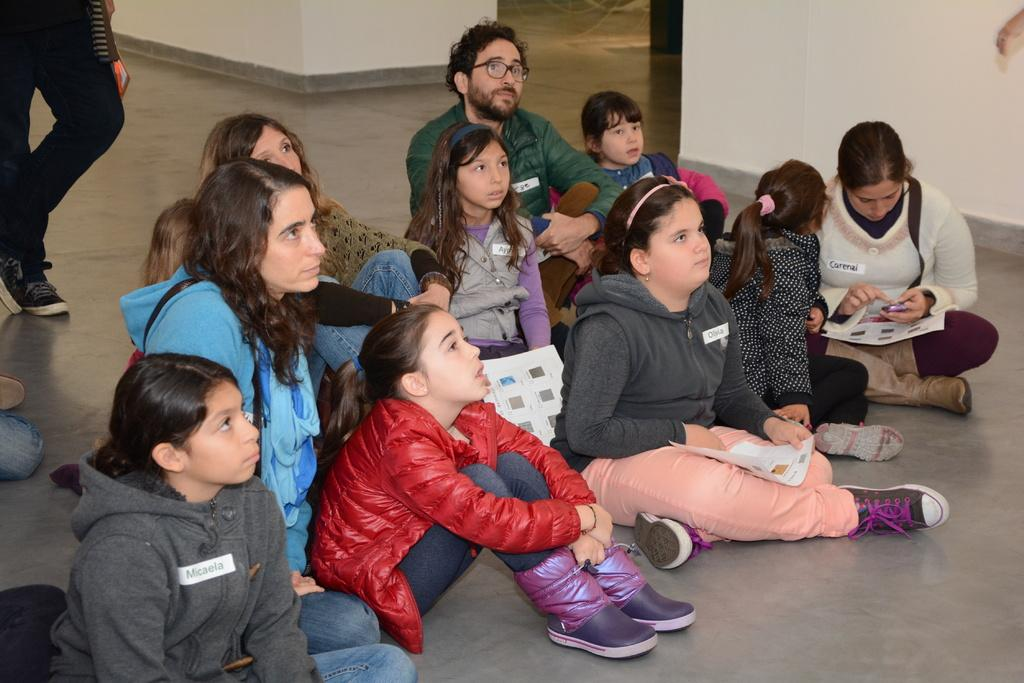What are the people in the image doing? There is a group of people sitting on the floor in the image. Are there any other people in the image besides those sitting on the floor? Yes, there is a person standing in the image. What can be seen in the background of the image? There is a wall visible in the background of the image. Where is the lunchroom located in the image? There is no mention of a lunchroom in the image; it only shows a group of people sitting on the floor and a person standing. What type of hat is the person wearing in the image? There is no person wearing a hat in the image. 